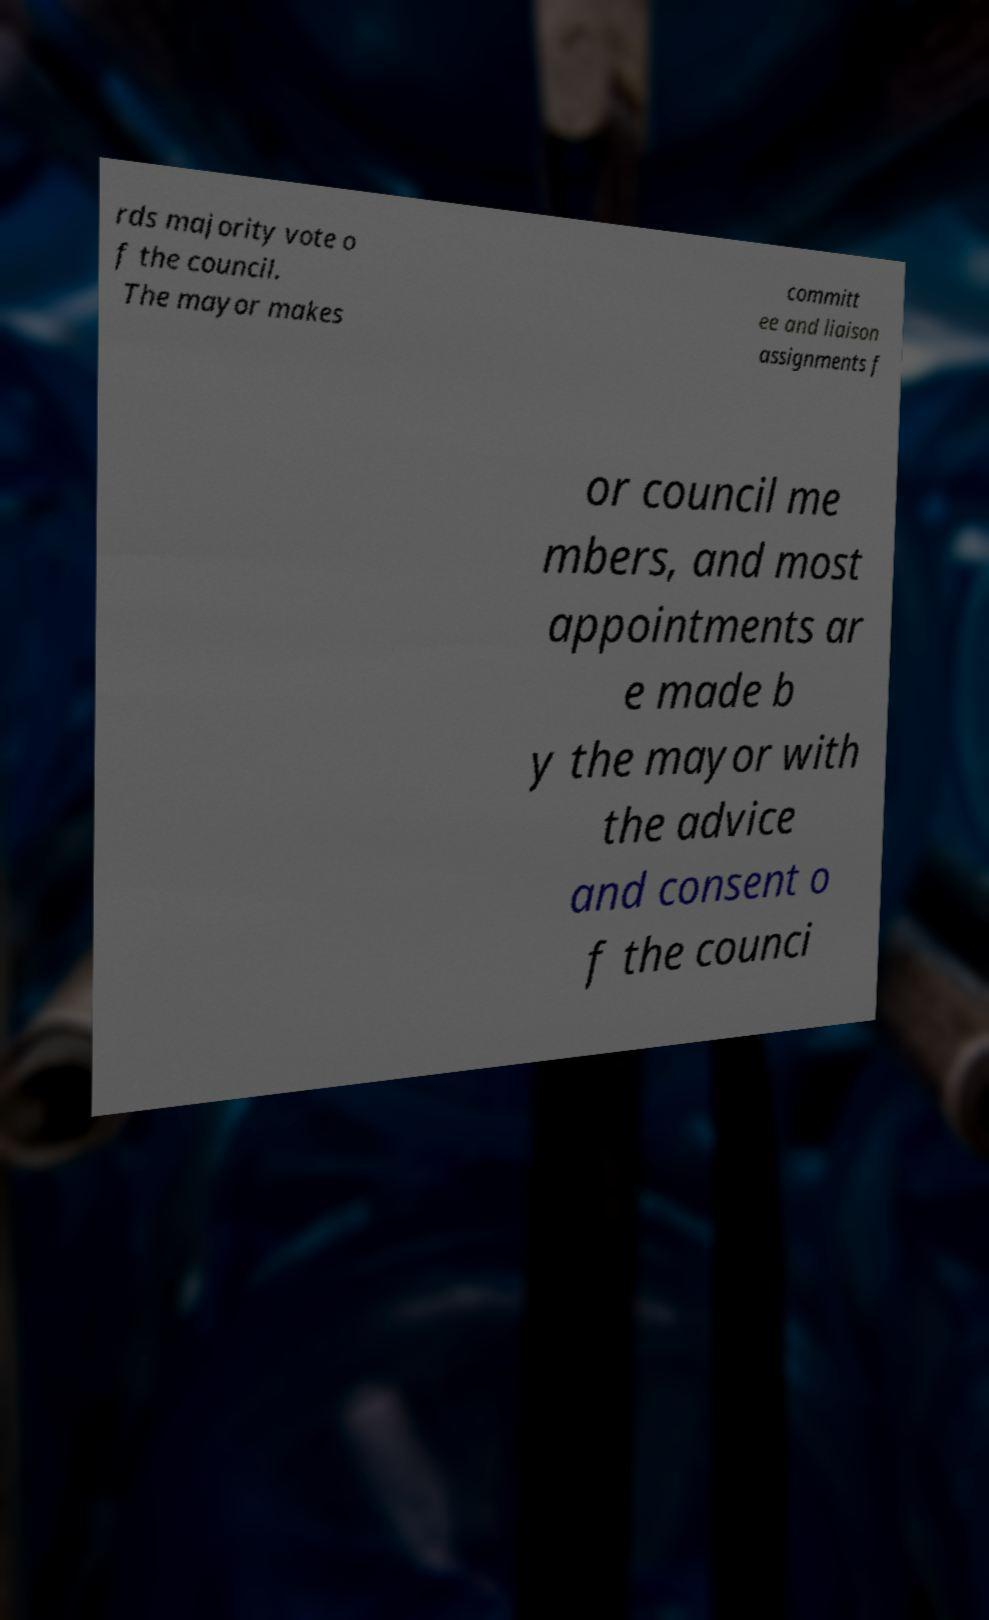What messages or text are displayed in this image? I need them in a readable, typed format. rds majority vote o f the council. The mayor makes committ ee and liaison assignments f or council me mbers, and most appointments ar e made b y the mayor with the advice and consent o f the counci 